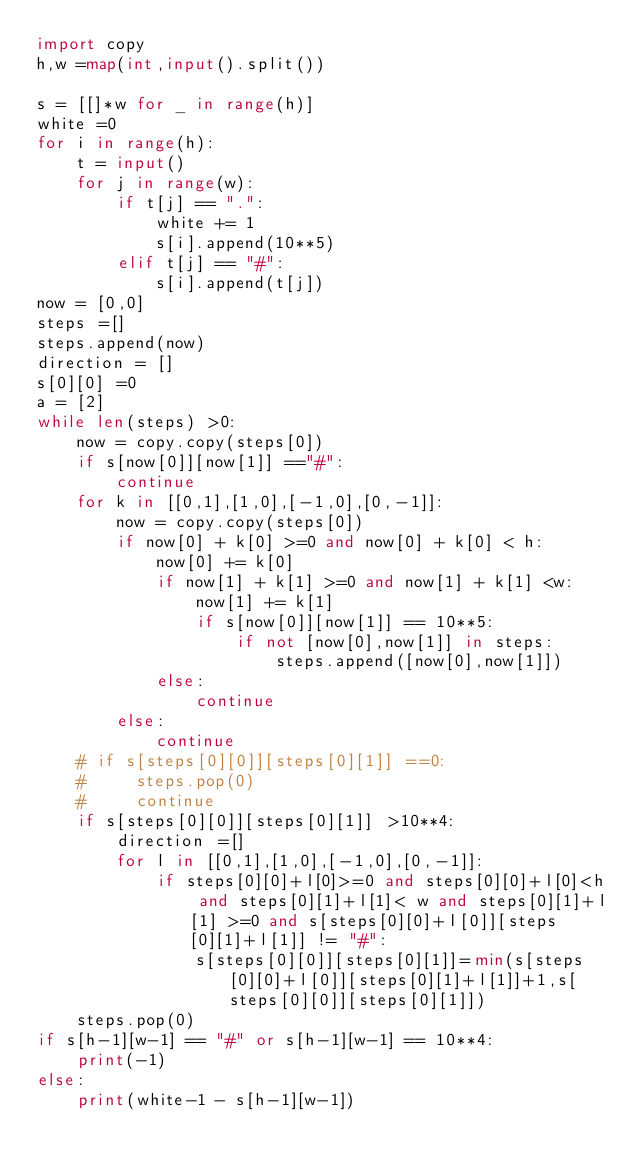<code> <loc_0><loc_0><loc_500><loc_500><_Python_>import copy
h,w =map(int,input().split())

s = [[]*w for _ in range(h)]
white =0
for i in range(h):
    t = input()
    for j in range(w):
        if t[j] == ".":
            white += 1
            s[i].append(10**5)
        elif t[j] == "#":
            s[i].append(t[j])
now = [0,0]
steps =[]
steps.append(now)
direction = []
s[0][0] =0
a = [2]
while len(steps) >0:
    now = copy.copy(steps[0])
    if s[now[0]][now[1]] =="#":
        continue
    for k in [[0,1],[1,0],[-1,0],[0,-1]]:
        now = copy.copy(steps[0])
        if now[0] + k[0] >=0 and now[0] + k[0] < h:
            now[0] += k[0]
            if now[1] + k[1] >=0 and now[1] + k[1] <w:
                now[1] += k[1]
                if s[now[0]][now[1]] == 10**5:
                    if not [now[0],now[1]] in steps:
                        steps.append([now[0],now[1]])
            else:
                continue
        else:
            continue
    # if s[steps[0][0]][steps[0][1]] ==0:
    #     steps.pop(0)
    #     continue
    if s[steps[0][0]][steps[0][1]] >10**4:
        direction =[]
        for l in [[0,1],[1,0],[-1,0],[0,-1]]:
            if steps[0][0]+l[0]>=0 and steps[0][0]+l[0]<h and steps[0][1]+l[1]< w and steps[0][1]+l[1] >=0 and s[steps[0][0]+l[0]][steps[0][1]+l[1]] != "#":
                s[steps[0][0]][steps[0][1]]=min(s[steps[0][0]+l[0]][steps[0][1]+l[1]]+1,s[steps[0][0]][steps[0][1]])
    steps.pop(0)
if s[h-1][w-1] == "#" or s[h-1][w-1] == 10**4:
    print(-1)
else:
    print(white-1 - s[h-1][w-1])







</code> 